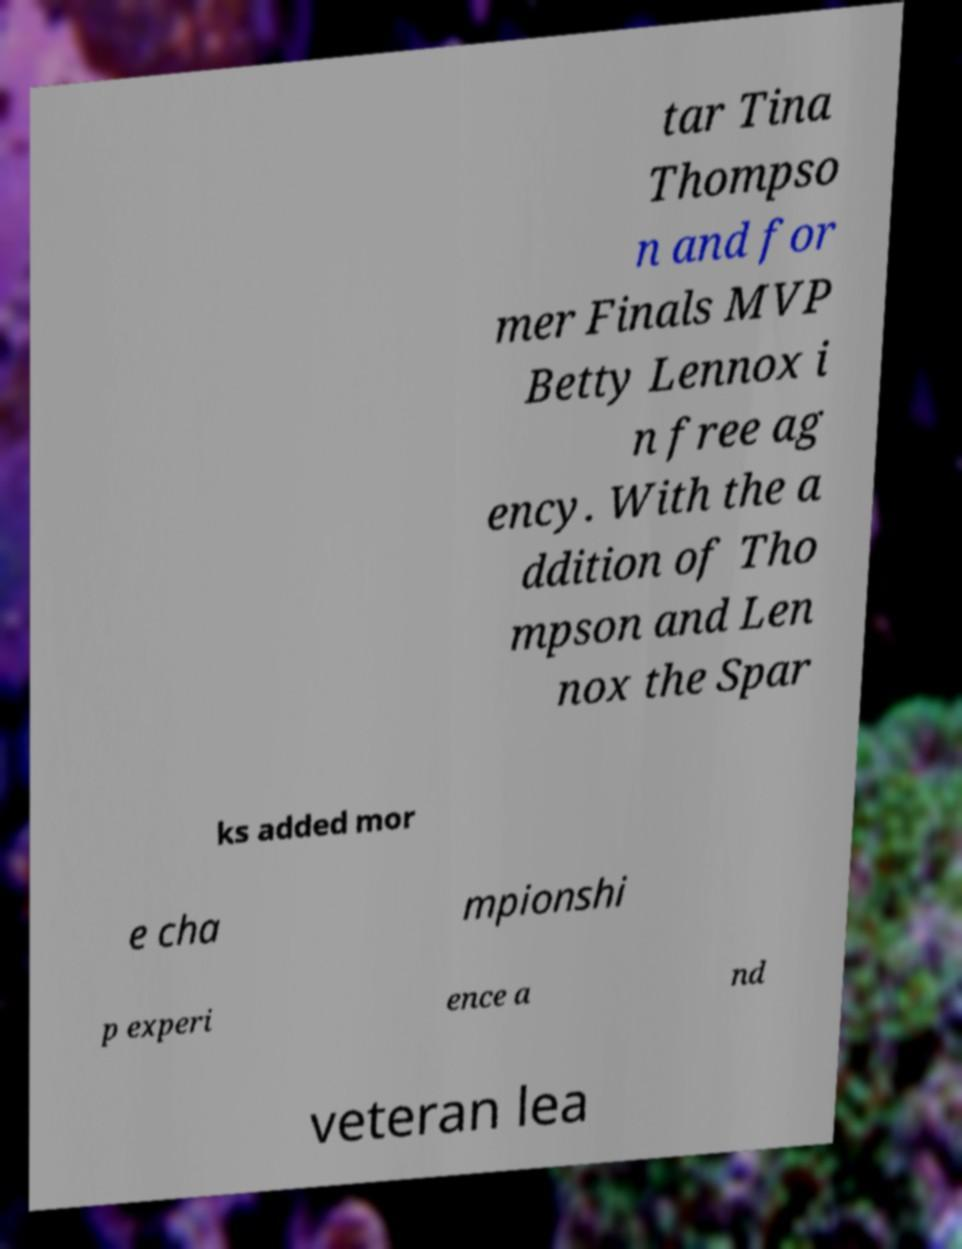Can you accurately transcribe the text from the provided image for me? tar Tina Thompso n and for mer Finals MVP Betty Lennox i n free ag ency. With the a ddition of Tho mpson and Len nox the Spar ks added mor e cha mpionshi p experi ence a nd veteran lea 